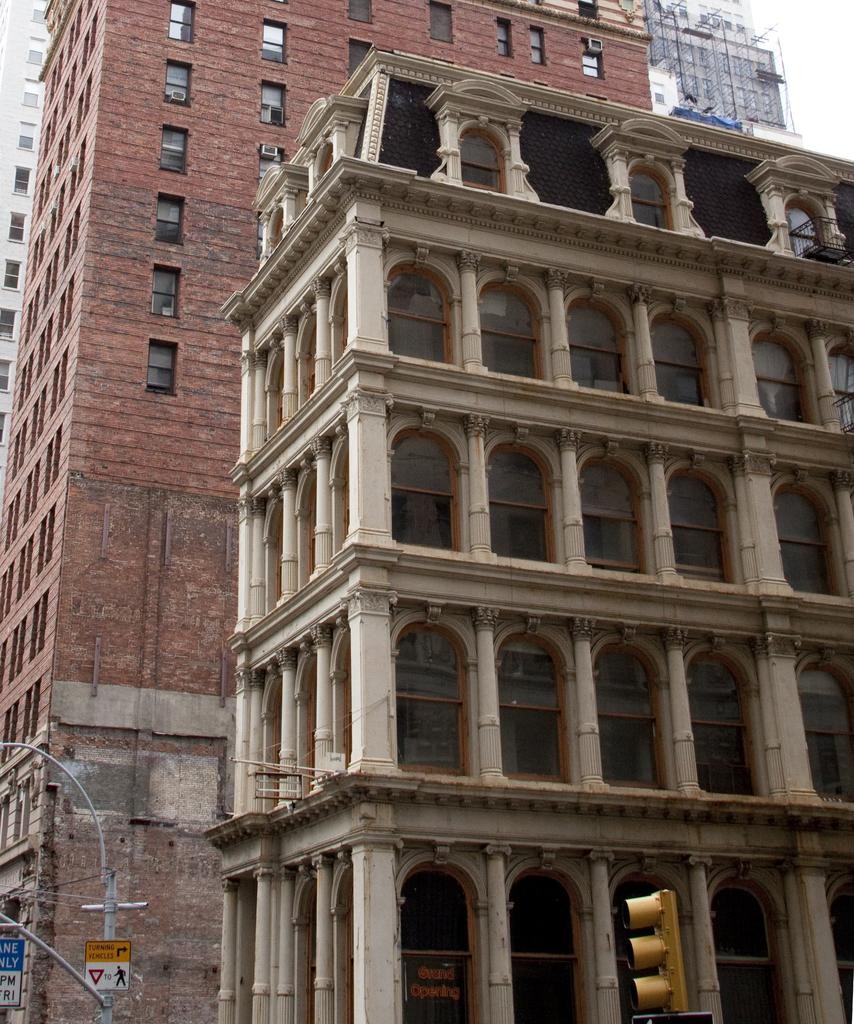What type of structures can be seen in the image? There are buildings in the image. Where is the pole located in the image? The pole is on the left side of the image. What type of information might be conveyed by the sign boards in the image? The sign boards in the image might convey information about directions, advertisements, or warnings. How does the wealth of the people in the image relate to the presence of the pole? There is no information about the wealth of the people in the image, nor any indication that the pole is related to their wealth. --- Facts: 1. There is a person holding a book in the image. 2. The person is sitting on a chair. 3. There is a table in front of the person. 4. The table has a lamp on it. Absurd Topics: dance, ocean, parrot Conversation: What is the person in the image holding? The person in the image is holding a book. What is the person's position in the image? The person is sitting on a chair. What object is in front of the person? There is a table in front of the person. What is on the table in the image? The table has a lamp on it. Reasoning: Let's think step by step in order to produce the conversation. We start by identifying the main subject in the image, which is the person holding a book. Then, we expand the conversation to include the person's position (sitting on a chair) and the objects in front of them (a table and a lamp). Each question is designed to elicit a specific detail about the image that is known from the provided facts. Absurd Question/Answer: Can you see any parrots dancing in the ocean in the image? There are no parrots or ocean present in the image; it features a person sitting on a chair holding a book, with a table and a lamp in front of them. 